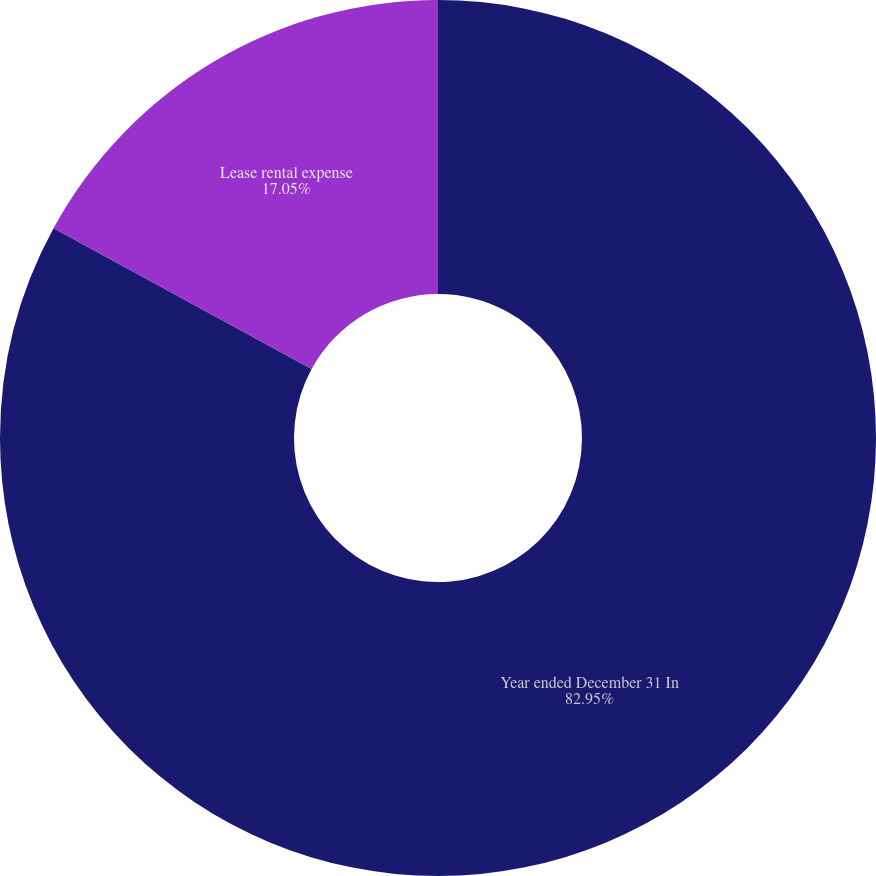Convert chart. <chart><loc_0><loc_0><loc_500><loc_500><pie_chart><fcel>Year ended December 31 In<fcel>Lease rental expense<nl><fcel>82.95%<fcel>17.05%<nl></chart> 